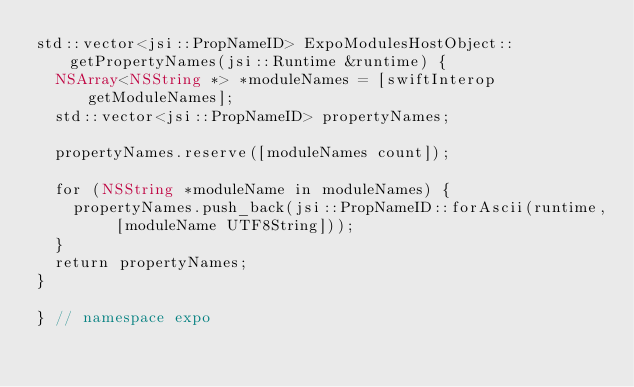Convert code to text. <code><loc_0><loc_0><loc_500><loc_500><_ObjectiveC_>std::vector<jsi::PropNameID> ExpoModulesHostObject::getPropertyNames(jsi::Runtime &runtime) {
  NSArray<NSString *> *moduleNames = [swiftInterop getModuleNames];
  std::vector<jsi::PropNameID> propertyNames;

  propertyNames.reserve([moduleNames count]);

  for (NSString *moduleName in moduleNames) {
    propertyNames.push_back(jsi::PropNameID::forAscii(runtime, [moduleName UTF8String]));
  }
  return propertyNames;
}

} // namespace expo
</code> 